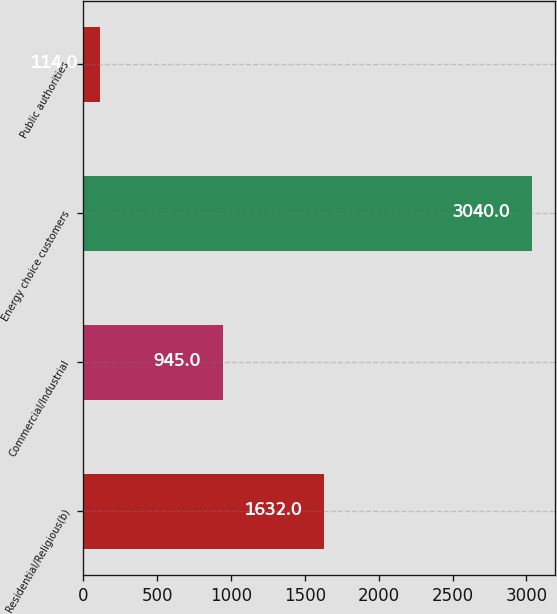Convert chart to OTSL. <chart><loc_0><loc_0><loc_500><loc_500><bar_chart><fcel>Residential/Religious(b)<fcel>Commercial/Industrial<fcel>Energy choice customers<fcel>Public authorities<nl><fcel>1632<fcel>945<fcel>3040<fcel>114<nl></chart> 